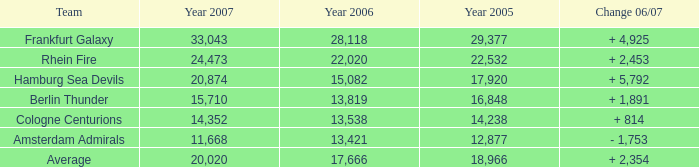What is the combined value of year 2007(s) when the year 2005 surpasses 29,377? None. 